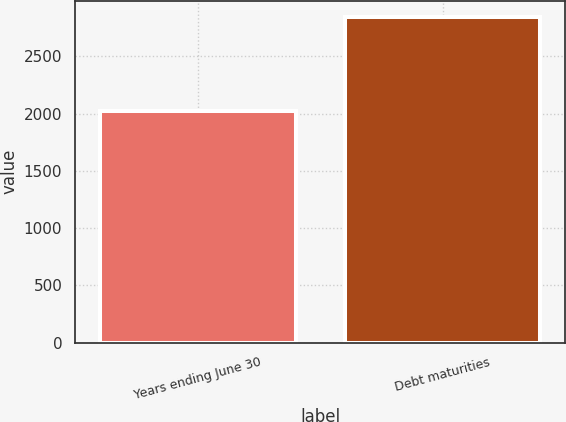Convert chart to OTSL. <chart><loc_0><loc_0><loc_500><loc_500><bar_chart><fcel>Years ending June 30<fcel>Debt maturities<nl><fcel>2022<fcel>2840<nl></chart> 